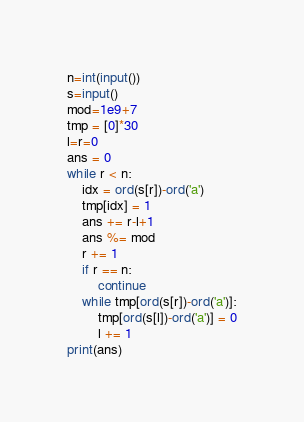<code> <loc_0><loc_0><loc_500><loc_500><_Python_>n=int(input())
s=input()
mod=1e9+7
tmp = [0]*30
l=r=0
ans = 0
while r < n:
    idx = ord(s[r])-ord('a')
    tmp[idx] = 1
    ans += r-l+1
    ans %= mod
    r += 1
    if r == n:
        continue
    while tmp[ord(s[r])-ord('a')]:
        tmp[ord(s[l])-ord('a')] = 0
        l += 1
print(ans)
</code> 